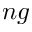Convert formula to latex. <formula><loc_0><loc_0><loc_500><loc_500>n g</formula> 